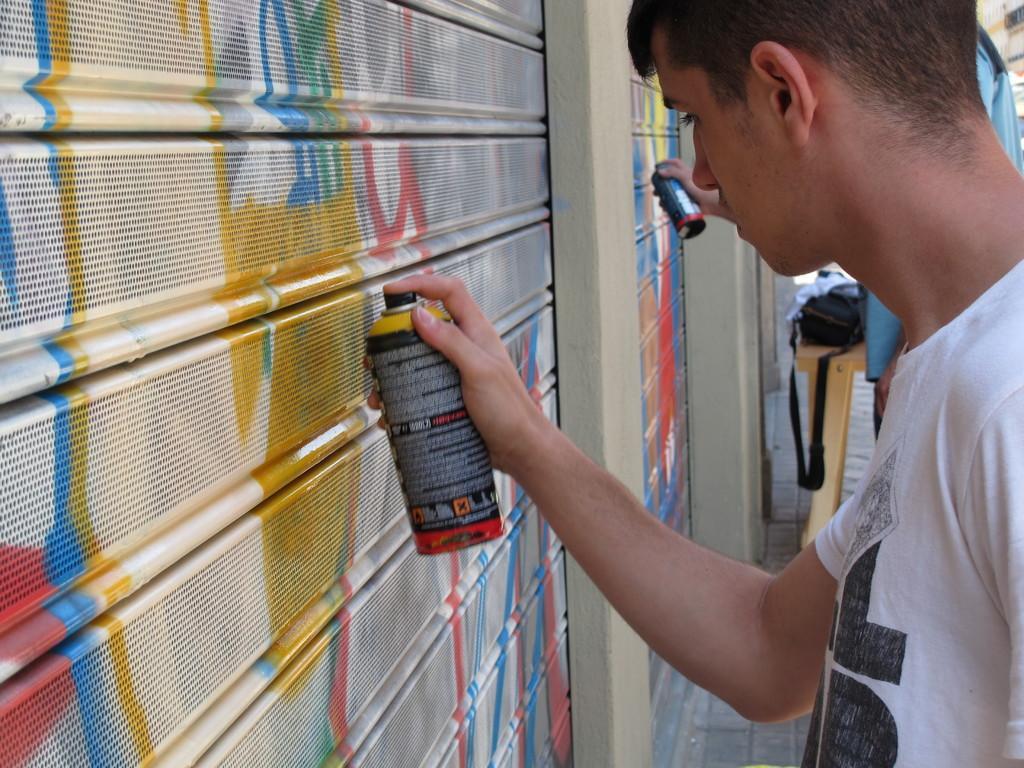Please provide a concise description of this image. In this image on the right side we can see two persons are standing and holding spray bottles in their hands. On the left side we can see shutters. In the background we can see bags on the table on the floor and other objects. 